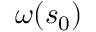Convert formula to latex. <formula><loc_0><loc_0><loc_500><loc_500>\omega ( s _ { 0 } )</formula> 